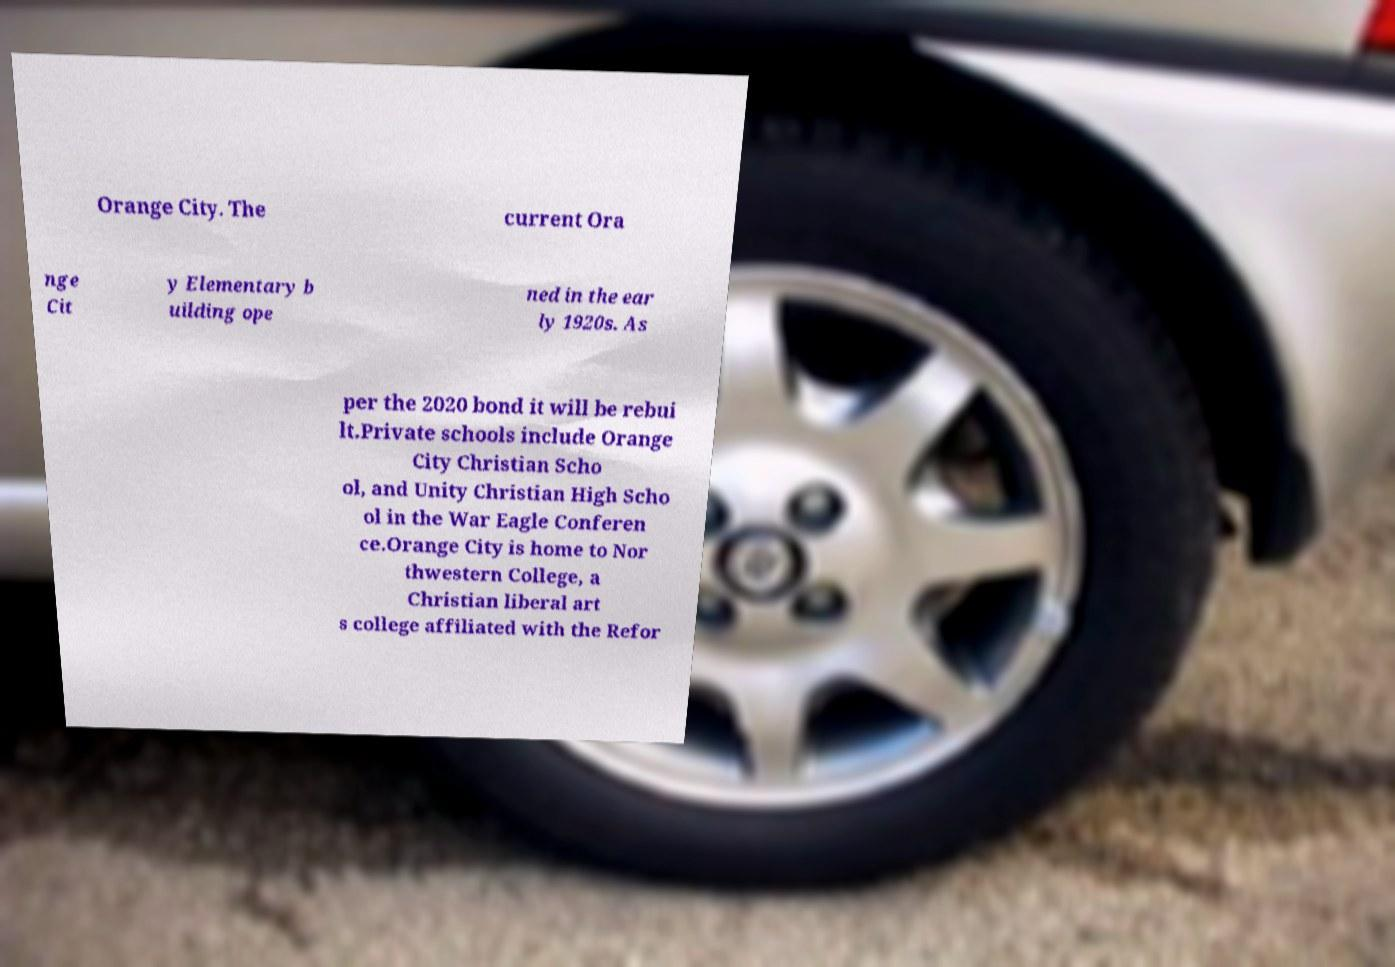Please identify and transcribe the text found in this image. Orange City. The current Ora nge Cit y Elementary b uilding ope ned in the ear ly 1920s. As per the 2020 bond it will be rebui lt.Private schools include Orange City Christian Scho ol, and Unity Christian High Scho ol in the War Eagle Conferen ce.Orange City is home to Nor thwestern College, a Christian liberal art s college affiliated with the Refor 